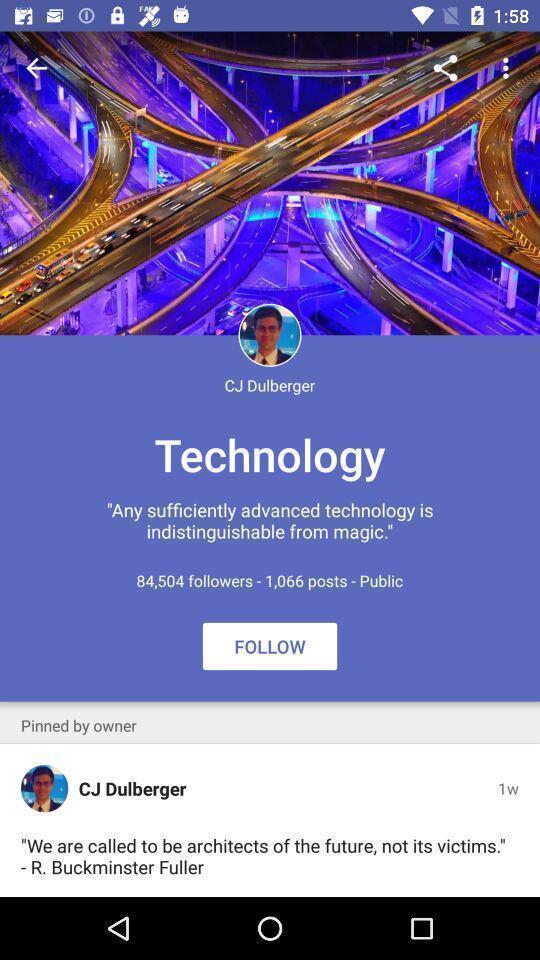Give me a summary of this screen capture. Profile page of a social account. 